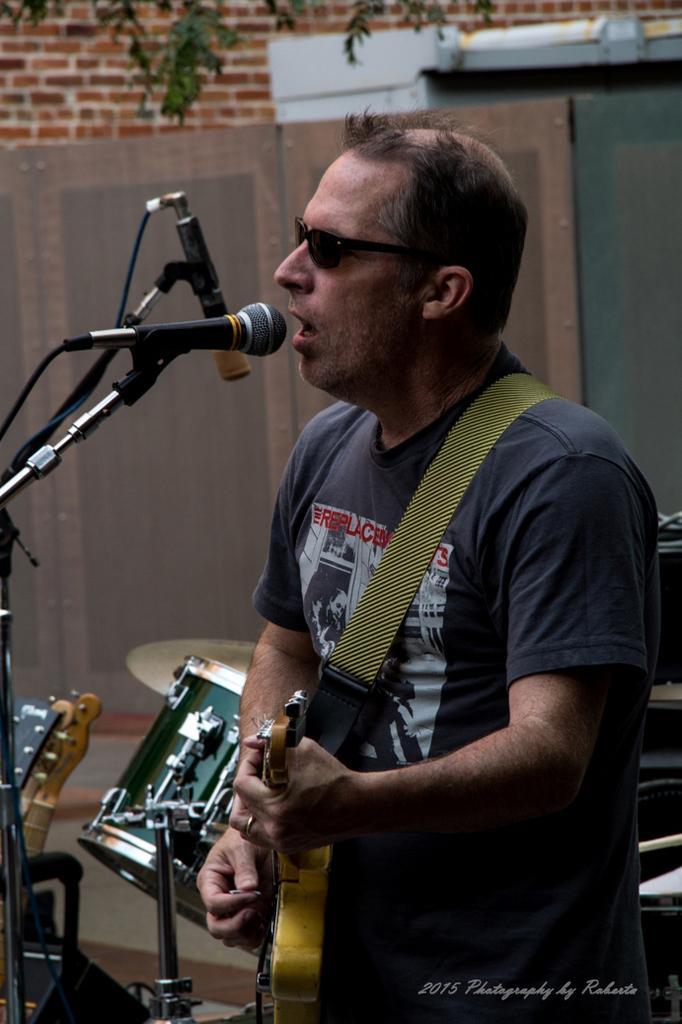Describe this image in one or two sentences. Here we can see a man standing and playing the guitar and singing, and in front here is the microphone, and at back here are the drums, and here is the wall made of bricks. 